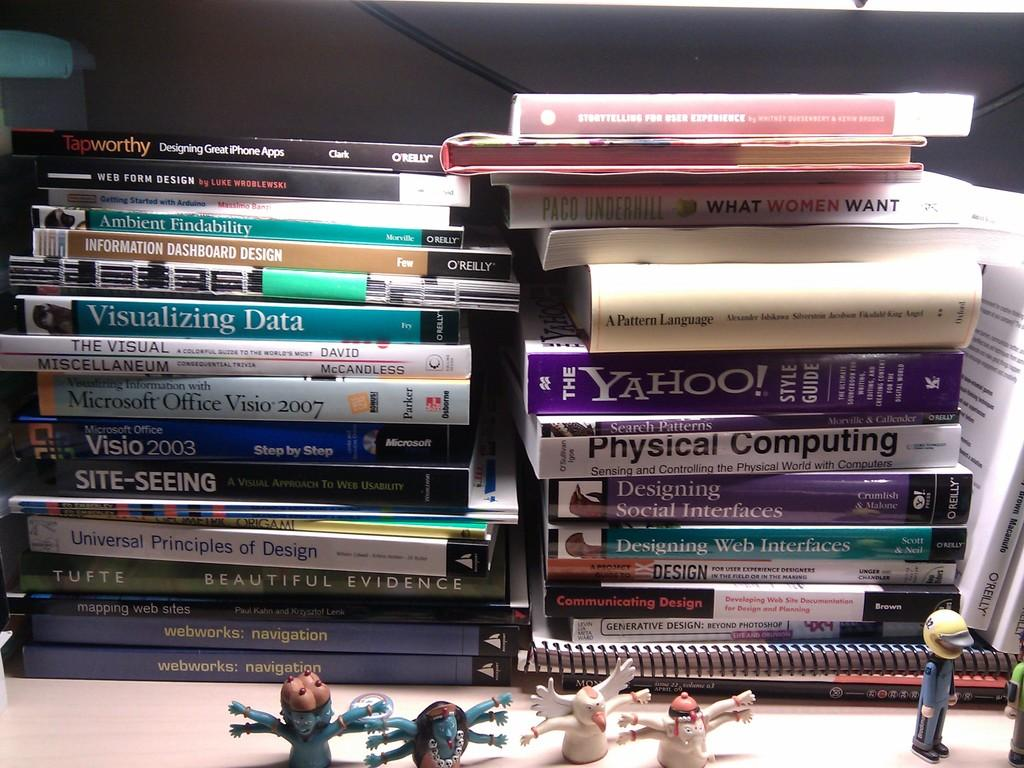<image>
Write a terse but informative summary of the picture. A book about visualizing data sits staked with many other books. 